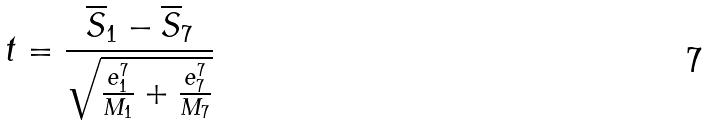Convert formula to latex. <formula><loc_0><loc_0><loc_500><loc_500>t = \frac { \overline { S } _ { 1 } - \overline { S } _ { 7 } } { \sqrt { \frac { e _ { 1 } ^ { 7 } } { M _ { 1 } } + \frac { e _ { 7 } ^ { 7 } } { M _ { 7 } } } }</formula> 